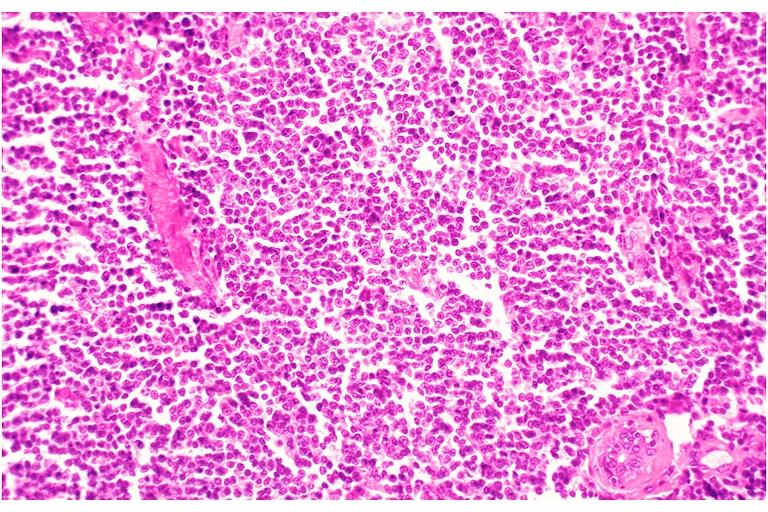what is present?
Answer the question using a single word or phrase. Oral 